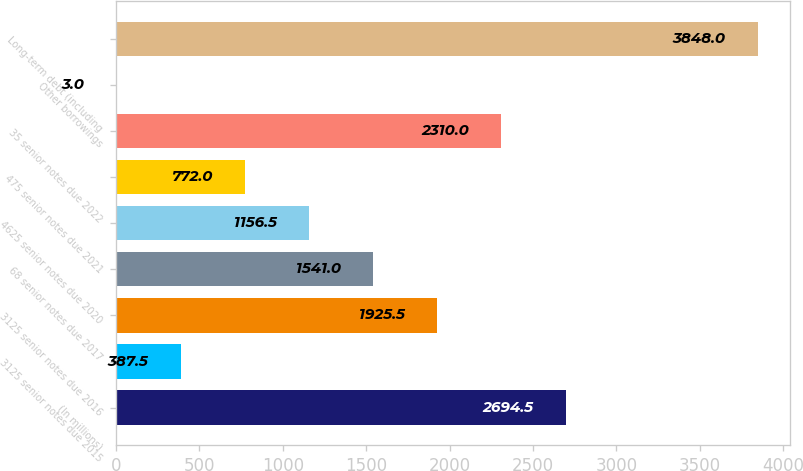Convert chart. <chart><loc_0><loc_0><loc_500><loc_500><bar_chart><fcel>(In millions)<fcel>3125 senior notes due 2015<fcel>3125 senior notes due 2016<fcel>68 senior notes due 2017<fcel>4625 senior notes due 2020<fcel>475 senior notes due 2021<fcel>35 senior notes due 2022<fcel>Other borrowings<fcel>Long-term debt (including<nl><fcel>2694.5<fcel>387.5<fcel>1925.5<fcel>1541<fcel>1156.5<fcel>772<fcel>2310<fcel>3<fcel>3848<nl></chart> 